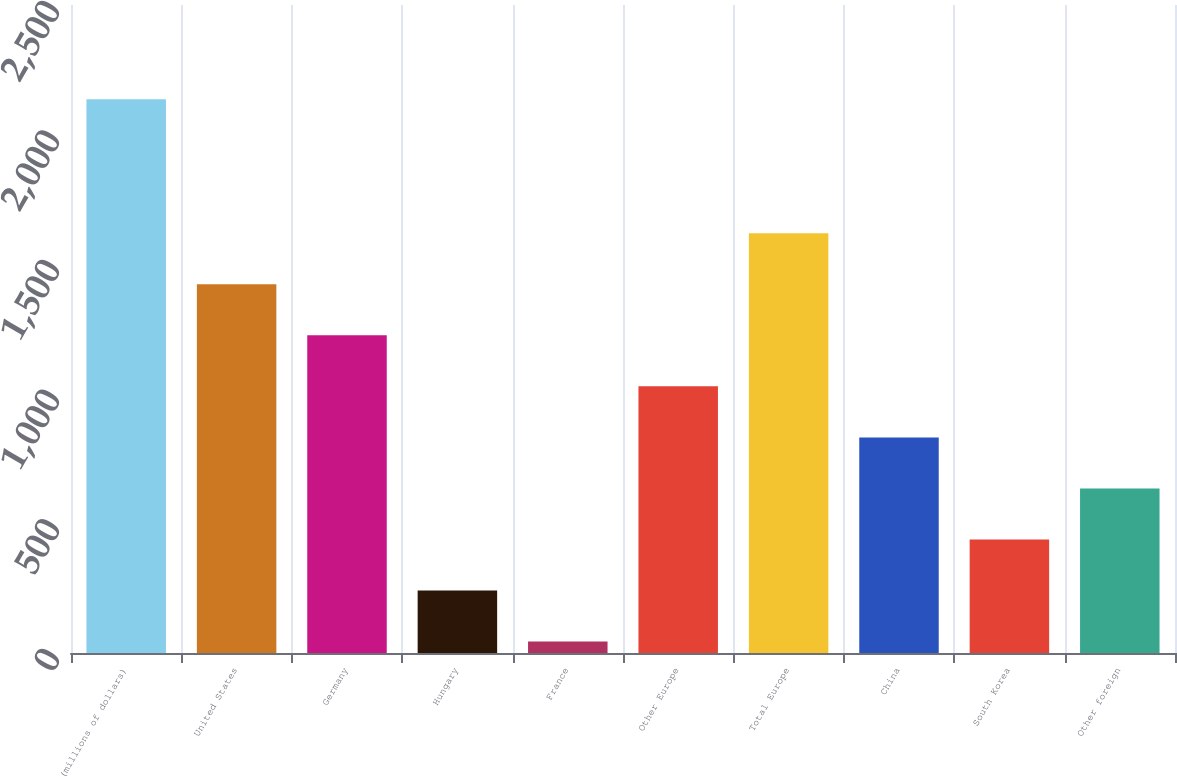<chart> <loc_0><loc_0><loc_500><loc_500><bar_chart><fcel>(millions of dollars)<fcel>United States<fcel>Germany<fcel>Hungary<fcel>France<fcel>Other Europe<fcel>Total Europe<fcel>China<fcel>South Korea<fcel>Other foreign<nl><fcel>2136.26<fcel>1422.42<fcel>1225.56<fcel>241.26<fcel>44.4<fcel>1028.7<fcel>1619.28<fcel>831.84<fcel>438.12<fcel>634.98<nl></chart> 